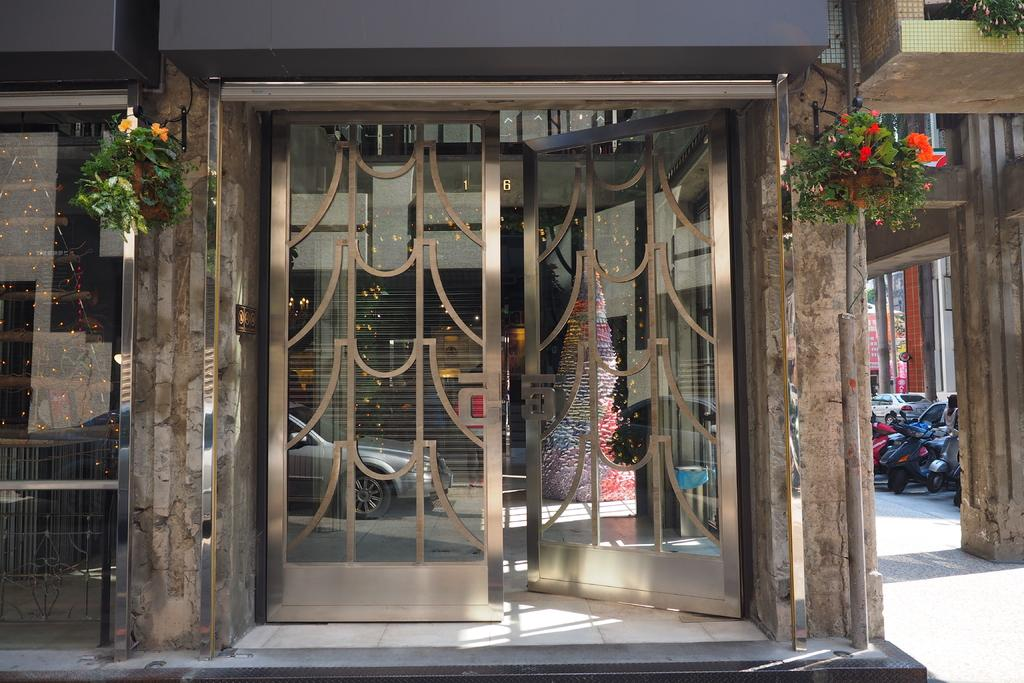What can be seen at the beginning of the path in the image? There is an entrance in the image. How is the entrance decorated? The entrance is decorated with a Christmas tree and flowers. What type of decoration is associated with the Christmas tree? The Christmas tree is a decoration itself, and it is part of the overall decoration of the entrance. What type of lip can be seen on the kettle in the image? There is no kettle or lip present in the image; the decoration consists of a Christmas tree and flowers. 